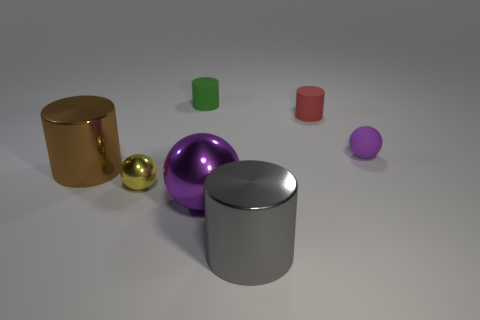Could you describe the lighting in the scene? The lighting in the scene is subtle and diffused, casting soft shadows under the objects, which indicates the presence of a soft and indirect light source, creating a calm and evenly lit composition. 